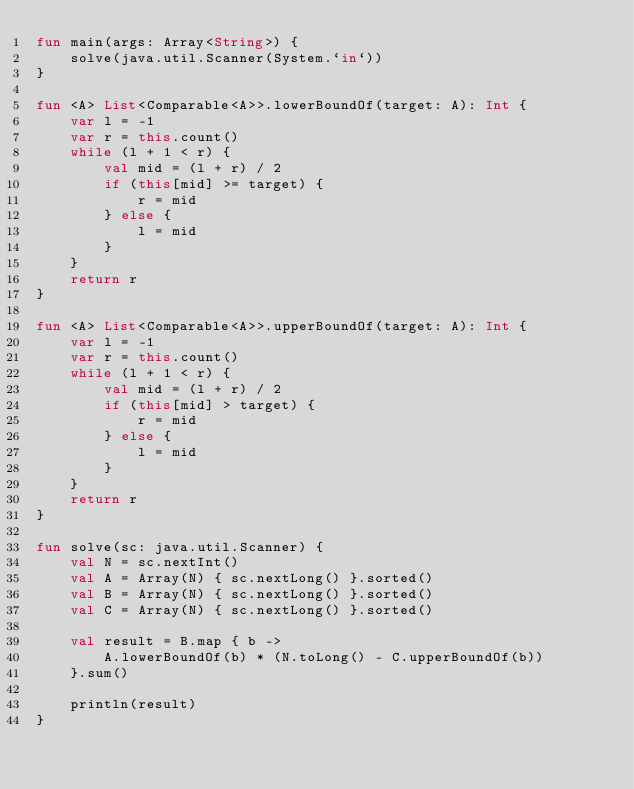<code> <loc_0><loc_0><loc_500><loc_500><_Kotlin_>fun main(args: Array<String>) {
    solve(java.util.Scanner(System.`in`))
}

fun <A> List<Comparable<A>>.lowerBoundOf(target: A): Int {
    var l = -1
    var r = this.count()
    while (l + 1 < r) {
        val mid = (l + r) / 2
        if (this[mid] >= target) {
            r = mid
        } else {
            l = mid
        }
    }
    return r
}

fun <A> List<Comparable<A>>.upperBoundOf(target: A): Int {
    var l = -1
    var r = this.count()
    while (l + 1 < r) {
        val mid = (l + r) / 2
        if (this[mid] > target) {
            r = mid
        } else {
            l = mid
        }
    }
    return r
}

fun solve(sc: java.util.Scanner) {
    val N = sc.nextInt()
    val A = Array(N) { sc.nextLong() }.sorted()
    val B = Array(N) { sc.nextLong() }.sorted()
    val C = Array(N) { sc.nextLong() }.sorted()

    val result = B.map { b ->
        A.lowerBoundOf(b) * (N.toLong() - C.upperBoundOf(b))
    }.sum()

    println(result)
}
</code> 